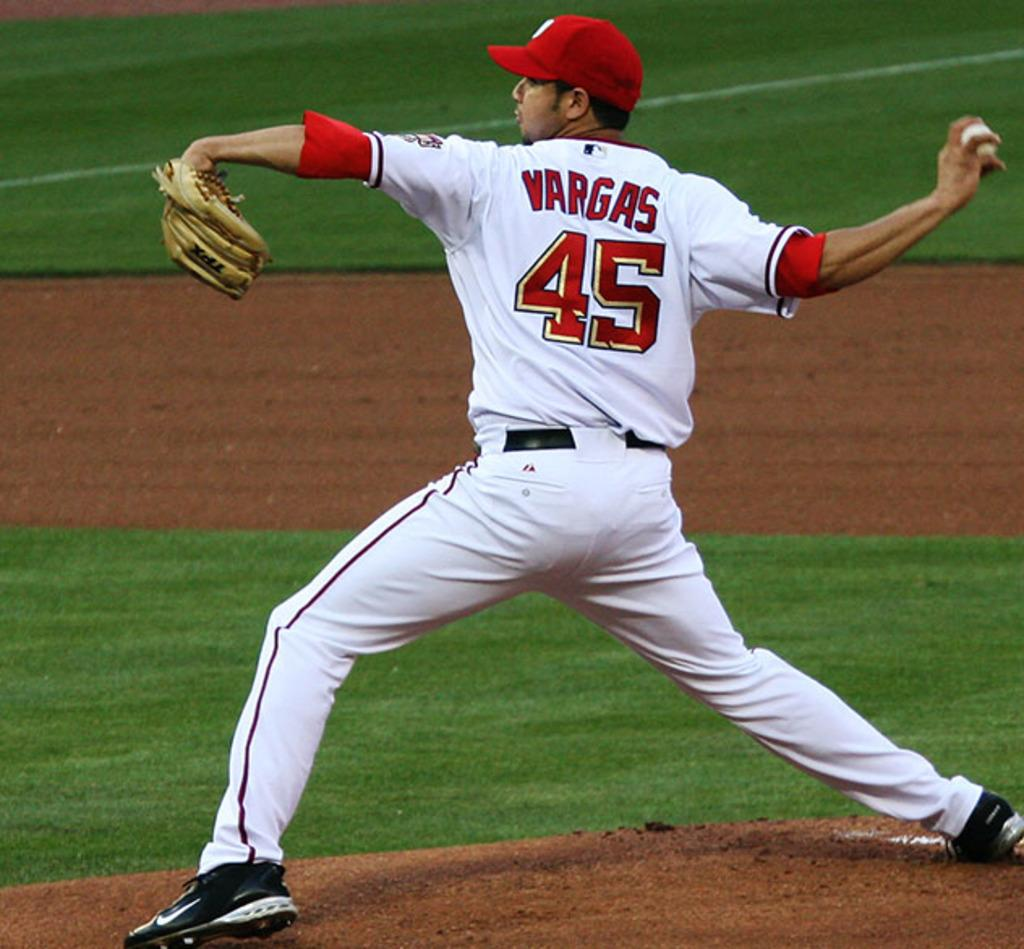<image>
Write a terse but informative summary of the picture. baseball pitcher with a circle englargment of a detail of grass 